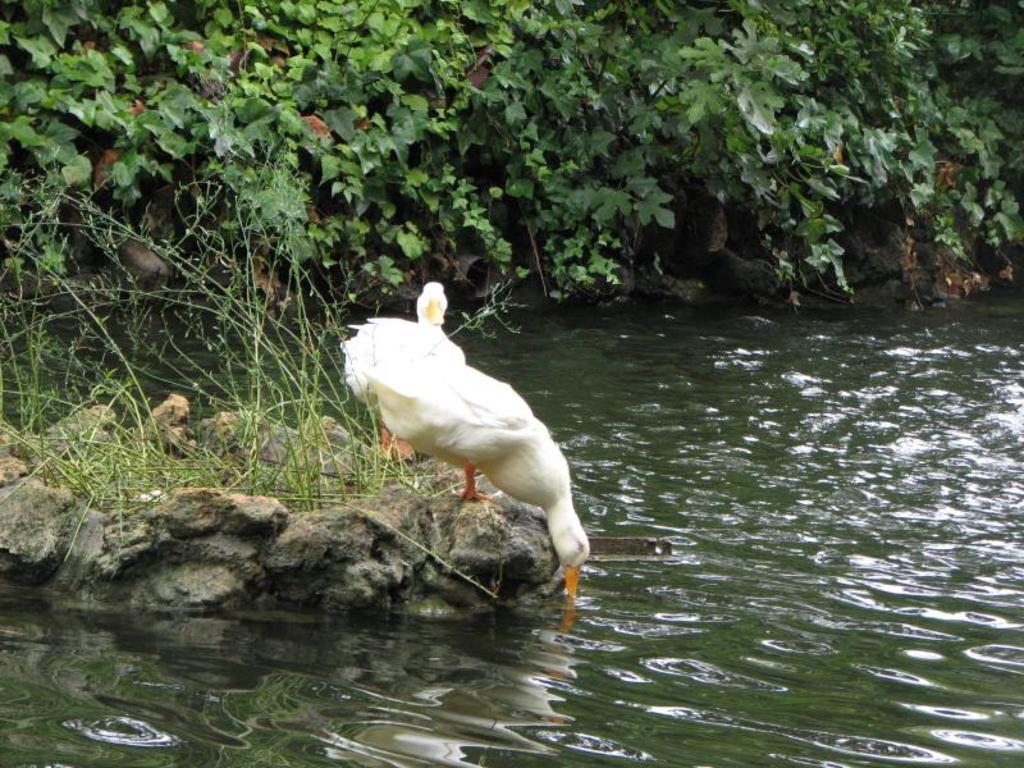Can you describe this image briefly? This image consists of two swans in white color. In the front, the swan is drinking water. At the bottom, there is water. On the left, we can see a rock. In the background, there are trees. 